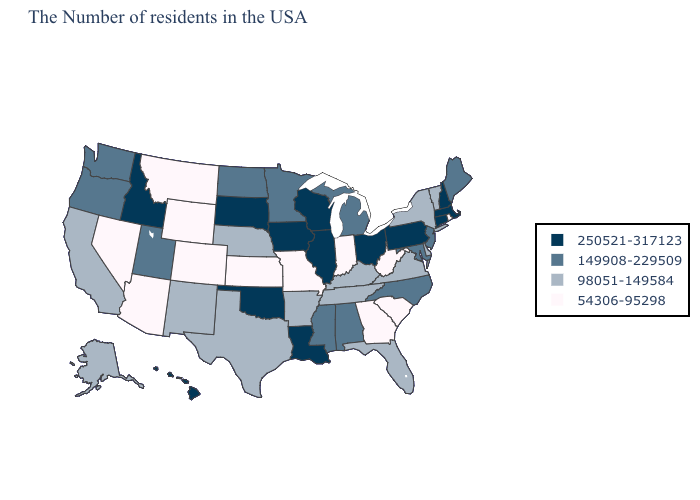What is the lowest value in the South?
Concise answer only. 54306-95298. Which states have the highest value in the USA?
Keep it brief. Massachusetts, New Hampshire, Connecticut, Pennsylvania, Ohio, Wisconsin, Illinois, Louisiana, Iowa, Oklahoma, South Dakota, Idaho, Hawaii. What is the highest value in states that border New York?
Concise answer only. 250521-317123. Name the states that have a value in the range 250521-317123?
Short answer required. Massachusetts, New Hampshire, Connecticut, Pennsylvania, Ohio, Wisconsin, Illinois, Louisiana, Iowa, Oklahoma, South Dakota, Idaho, Hawaii. Does Florida have a higher value than Utah?
Quick response, please. No. Name the states that have a value in the range 149908-229509?
Answer briefly. Maine, New Jersey, Maryland, North Carolina, Michigan, Alabama, Mississippi, Minnesota, North Dakota, Utah, Washington, Oregon. What is the value of Indiana?
Be succinct. 54306-95298. Does Georgia have the lowest value in the South?
Answer briefly. Yes. What is the value of Mississippi?
Concise answer only. 149908-229509. How many symbols are there in the legend?
Be succinct. 4. What is the lowest value in the South?
Keep it brief. 54306-95298. What is the value of Nebraska?
Write a very short answer. 98051-149584. What is the value of Arizona?
Write a very short answer. 54306-95298. What is the value of Arkansas?
Write a very short answer. 98051-149584. Among the states that border Wisconsin , which have the highest value?
Short answer required. Illinois, Iowa. 